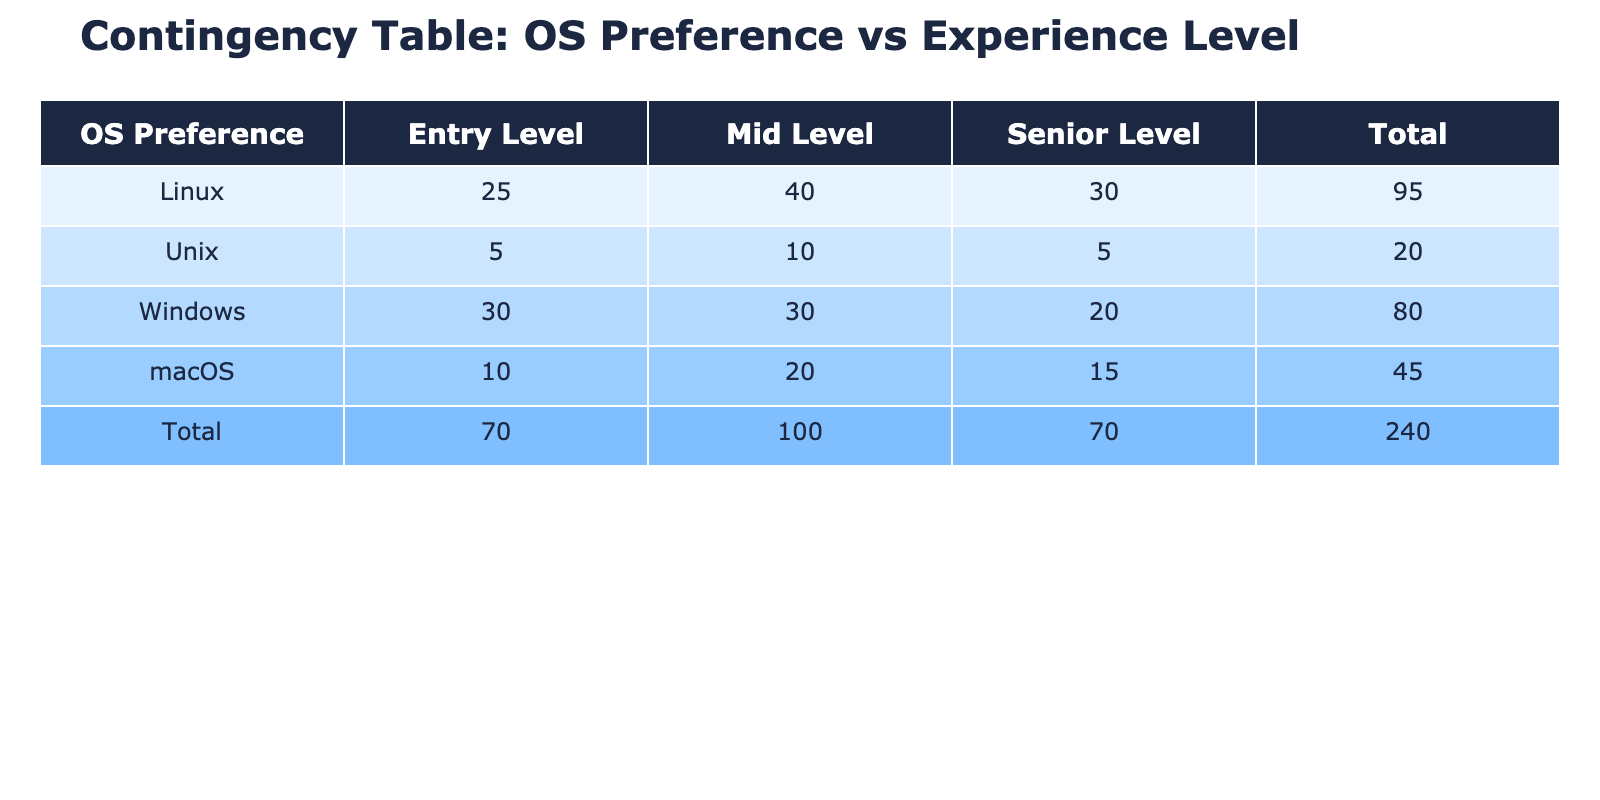What is the total frequency of programmers preferring Windows? To find the total frequency for Windows, I will look at the "Windows" row and add the values from all experience levels: Entry Level (30) + Mid Level (30) + Senior Level (20) = 80.
Answer: 80 Which Operating System has the highest total frequency among all levels? I will check the total frequencies for each Operating System. The totals are: Linux (95), Windows (80), macOS (45), Unix (20). The highest total is for Linux with 95.
Answer: Linux Is the number of Entry Level programmers using Linux greater than the number of Senior Level programmers using any OS? The frequency of Entry Level Linux programmers is 25 and the Senior Level frequencies are: Windows (20), macOS (15), and Unix (5). 25 is greater than all Senior Level values, therefore the statement is true.
Answer: Yes What is the combined frequency of macOS and Unix for Mid Level programmers? For Mid Level programmers, I will look at the frequencies for macOS (20) and Unix (10). The combined frequency is 20 + 10 = 30.
Answer: 30 What is the ratio of Linux to Windows users at the Mid Level? Looking at the Mid Level frequencies, Linux has 40 users and Windows has 30 users. The ratio is calculated as 40:30, which simplifies to 4:3.
Answer: 4:3 What is the minimum frequency of all OS preferences across all levels? I will review the frequencies from the table. The minimum values are: Linux (25), Windows (20), macOS (10), and Unix (5). The minimum among these is Unix with a frequency of 5.
Answer: 5 Does the total number of programmers preferring Windows exceed that of macOS? The total for Windows is 80 and for macOS it is 45. Since 80 is greater than 45, the statement is true.
Answer: Yes What is the total number of programmers across all experience levels for Linux? From the table, I will add all frequencies for Linux: Entry Level (25), Mid Level (40), Senior Level (30). The total is 25 + 40 + 30 = 95.
Answer: 95 